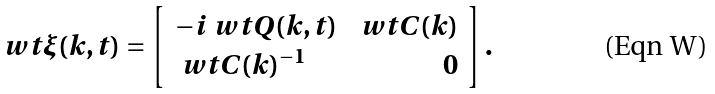<formula> <loc_0><loc_0><loc_500><loc_500>\ w t \xi ( k , t ) = \left [ \begin{array} { l r } - i \ w t Q ( k , t ) & \ w t C ( k ) \\ \ w t C ( k ) ^ { - 1 } & 0 \end{array} \right ] .</formula> 